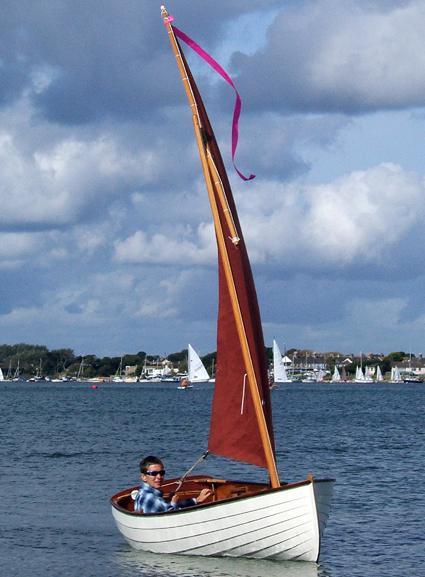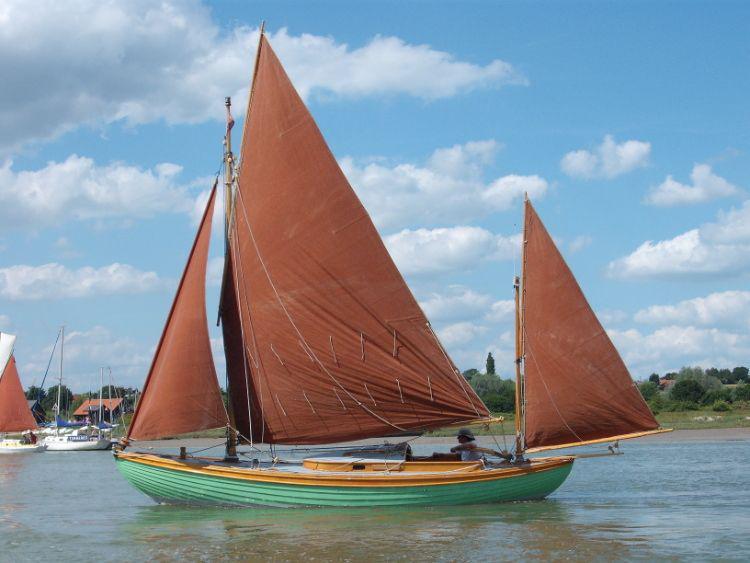The first image is the image on the left, the second image is the image on the right. Evaluate the accuracy of this statement regarding the images: "In the left image there is a person in a boat wearing a hate with two raised sails". Is it true? Answer yes or no. No. The first image is the image on the left, the second image is the image on the right. Assess this claim about the two images: "All the sails are white.". Correct or not? Answer yes or no. No. 